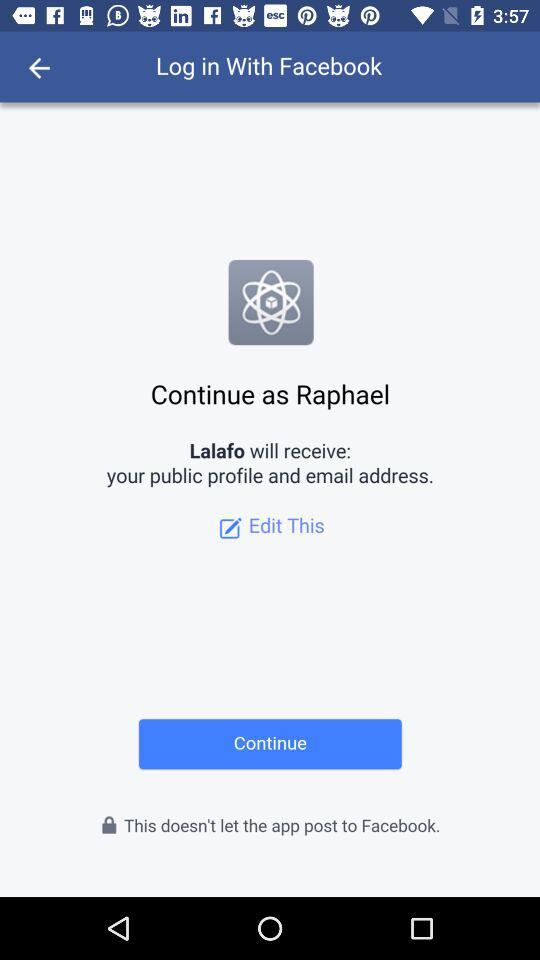What is the user name? The user name is Raphael. 